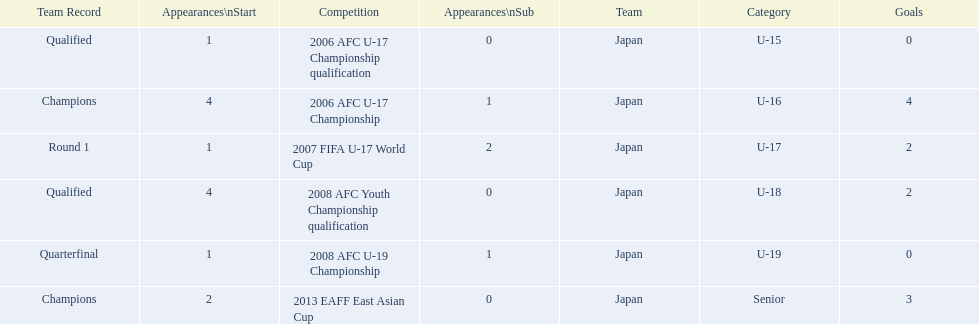Name the earliest competition to have a sub. 2006 AFC U-17 Championship. 